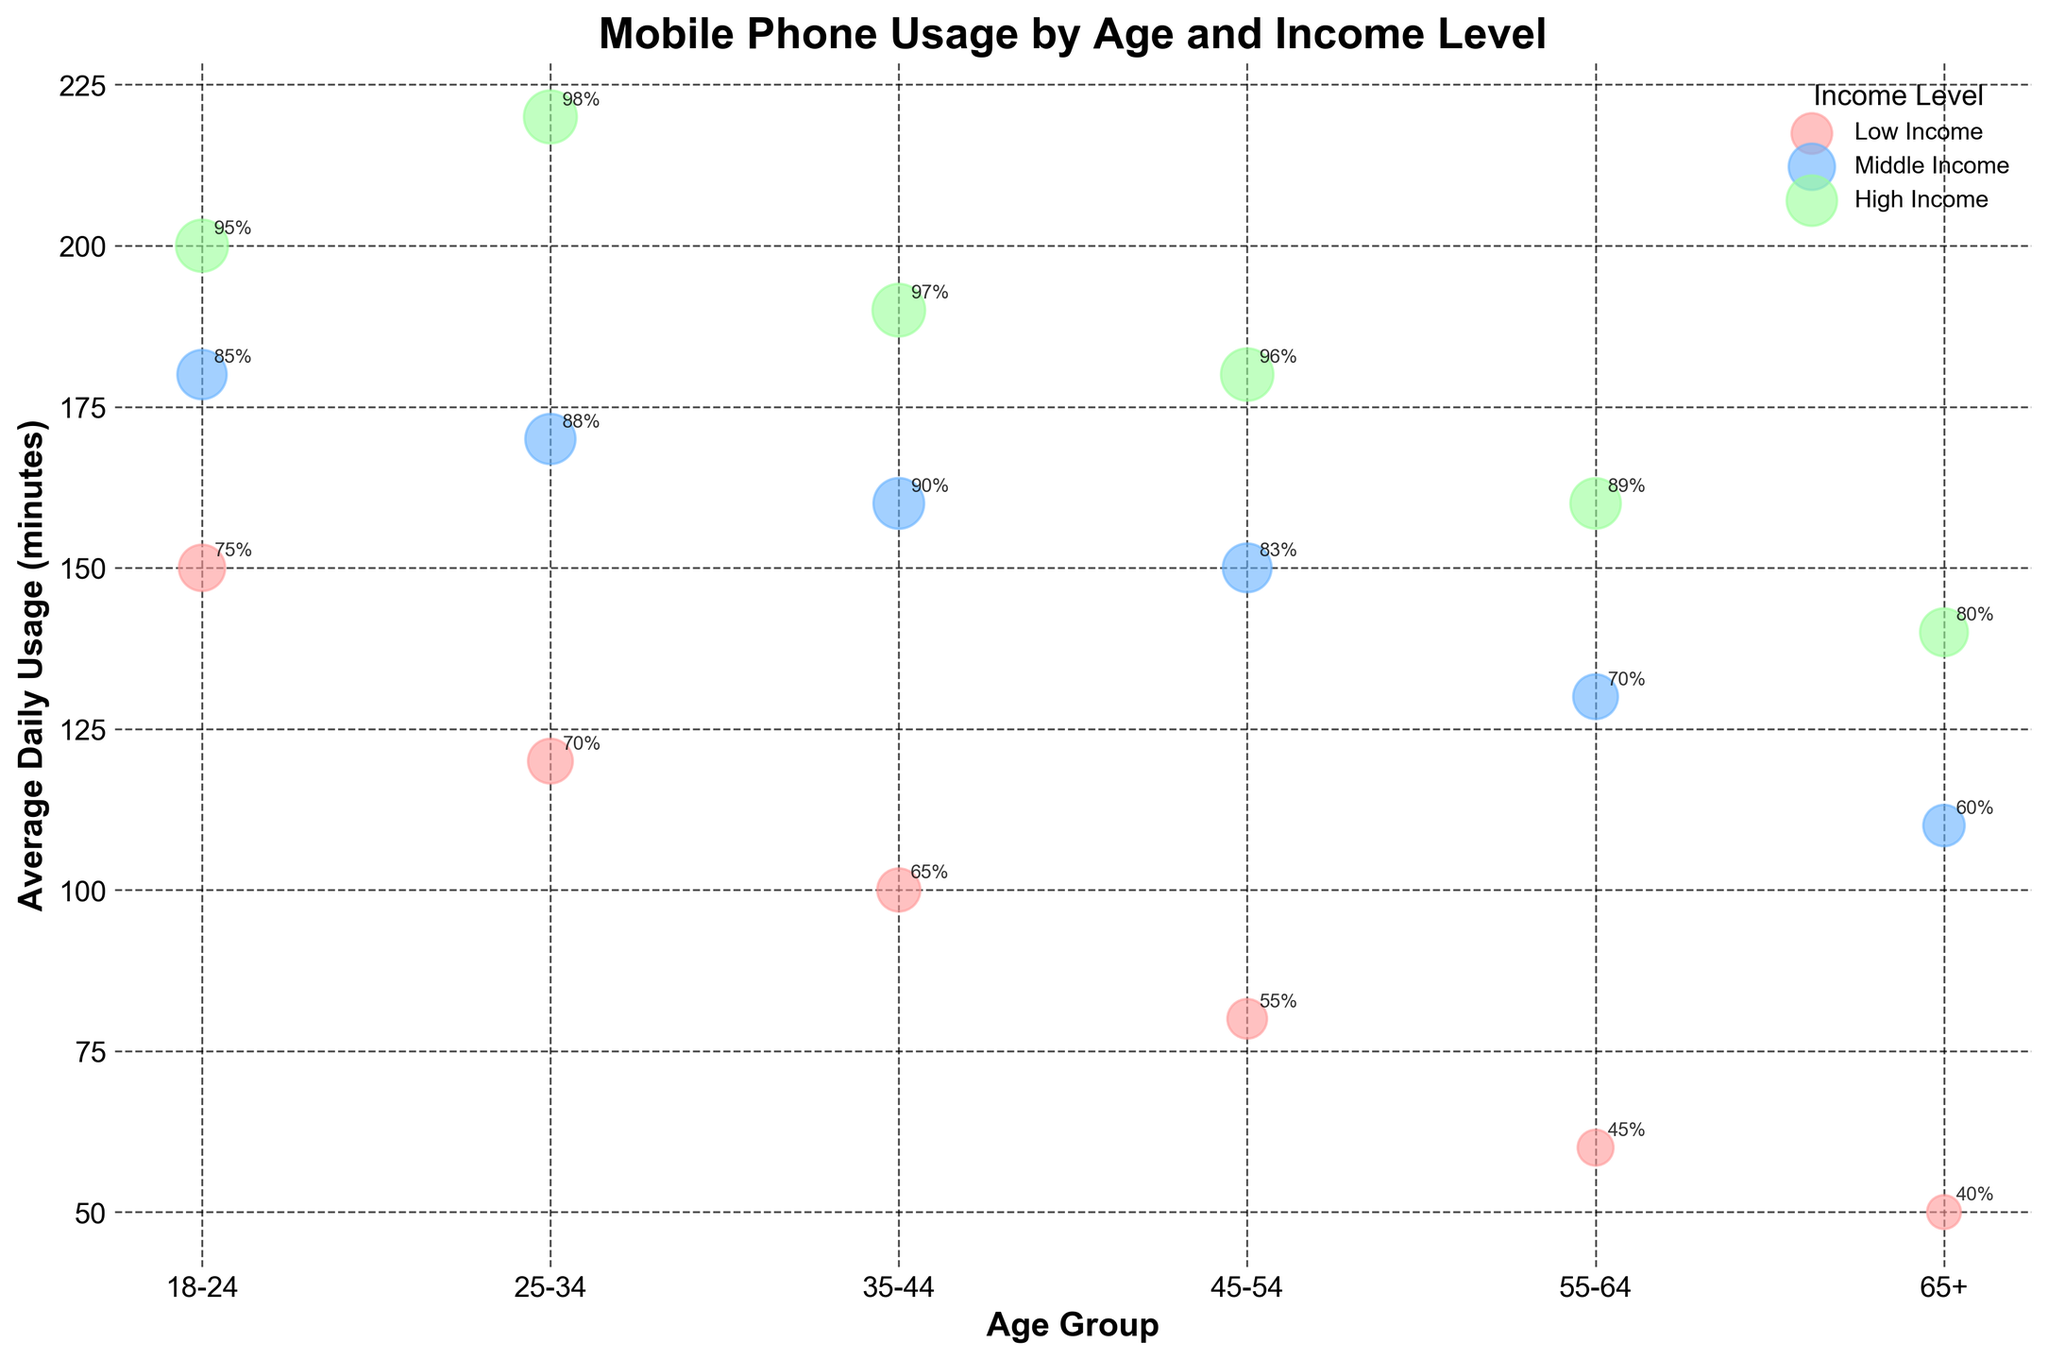What's the title of the plot? The title of the plot is a basic element that is typically displayed at the top of the figure.
Answer: Mobile Phone Usage by Age and Income Level Which age group shows the highest average daily usage for high-income individuals? Look at the data points categorized under 'High Income' and identify which age group has the highest y-value for 'Average Daily Usage (minutes)'.
Answer: 25-34 What is the average daily usage for middle-income individuals aged 55-64? Identify the data point for individuals aged 55-64 in the 'Middle Income' category and read the corresponding y-value.
Answer: 130 minutes How many unique income levels are represented in the plot? Count the distinct colors or labels in the legend that represent different income levels.
Answer: 3 Which group has the lowest percentage with smartphone access? Look for the smallest bubble on the plot and check to which age group and income level it corresponds to.
Answer: 65+, Low Income What is the difference in average daily usage between high-income individuals aged 18-24 and high-income individuals aged 35-44? First, locate the average daily usage values for high-income individuals aged 18-24 and 35-44. Then, calculate the difference between these two values (200 - 190).
Answer: 10 minutes What income level and age group combination has the highest percentage with smartphone access? Identify the largest bubble and determine the associated age group and income level.
Answer: 25-34, High Income Compare the percentage with smartphone access for low-income individuals aged 35-44 and middle-income individuals aged 35-44. Which group has a higher percentage? Locate the bubbles for low-income and middle-income individuals in the 35-44 age group. Compare the sizes, which represent the percentage with smartphone access (65% for Low Income and 90% for Middle Income).
Answer: Middle Income How does the average daily mobile usage for low-income individuals change from the 18-24 age group to the 45-54 age group? Find the 'Average Daily Usage (minutes)' values for low-income individuals in the 18-24 and 45-54 age groups and compare them (150 vs. 80).
Answer: It decreases What is the percentage difference in smartphone access between high-income and low-income individuals aged 45-54? Identify the 'Percentage with Smartphone Access' for high-income (96%) and low-income (55%) individuals in the 45-54 age group. Calculate the difference (96 - 55).
Answer: 41% 